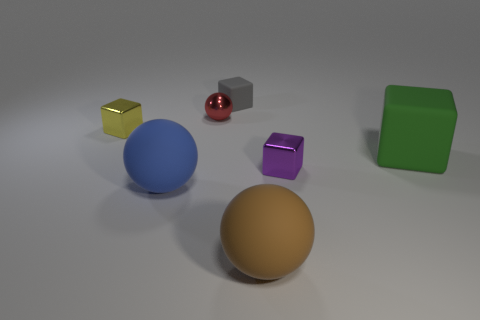What could be the purpose of arranging these objects together? This arrangement seems purposeful, likely set up to compare and contrast the visual properties of different objects. It might be a part of a study or demonstration in color theory, material properties, lighting effects, or even a simple artistic composition. The colors are primary and secondary, which could suggest an educational purpose to teach about color mixing. The differing sizes and textures also provide an opportunity to discuss perspective and depth in a two-dimensional representation of a three-dimensional space. 